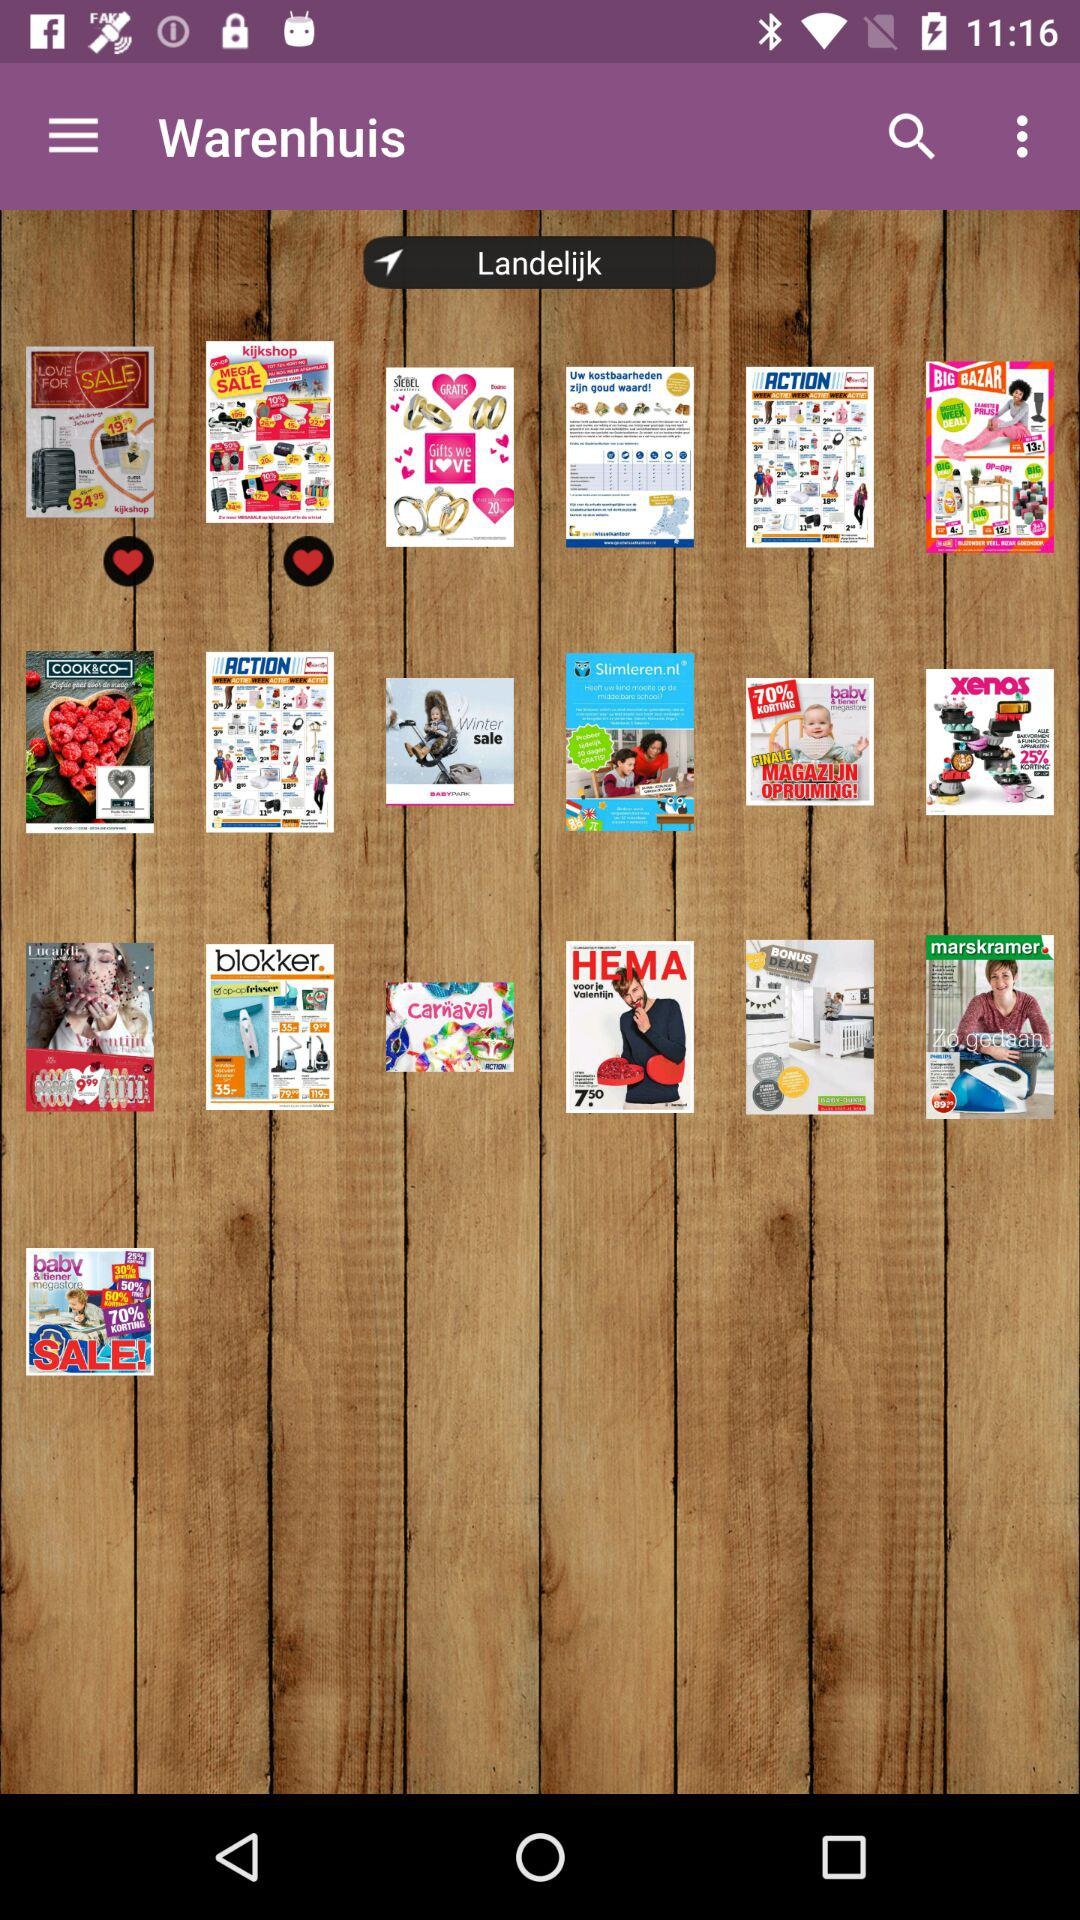What is the application name? The application name is "Warenhuis". 